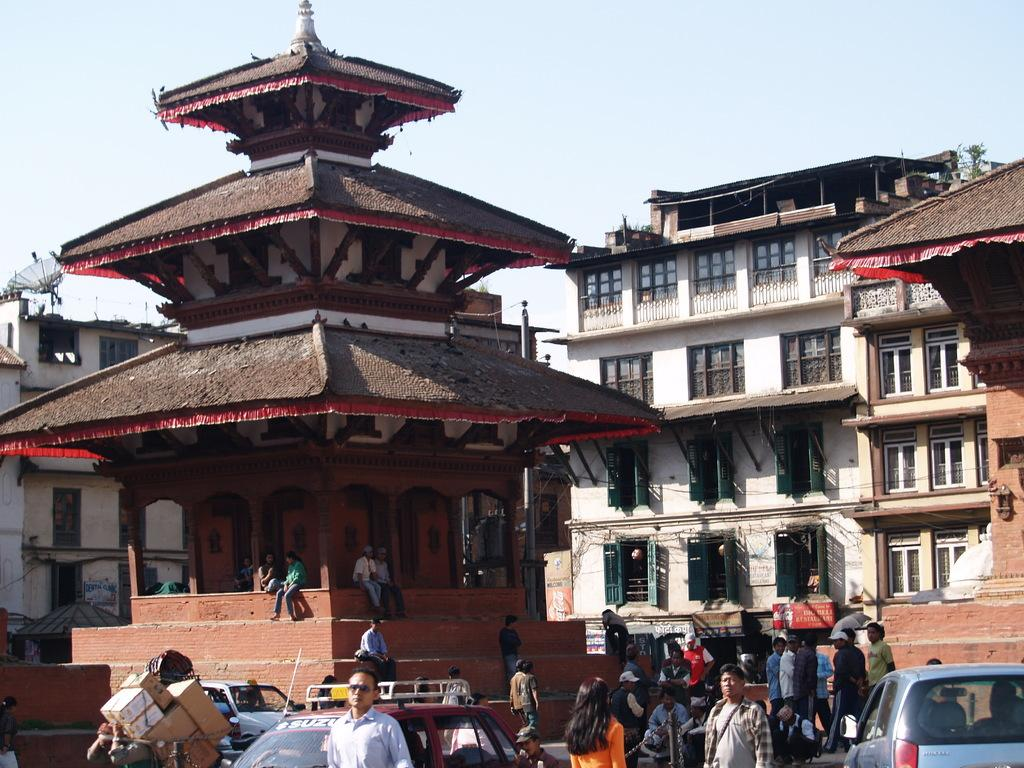Who or what can be seen in the image? There are people and vehicles in the image. What else is present in the image besides people and vehicles? There are boxes, ancient architectures, and buildings visible in the image. What can be seen in the background of the image? Windows, an antenna, and the sky are visible in the background of the image. What type of pail is being used by the people in the image? There is no pail present in the image. How does the tramp interact with the ancient architecture in the image? There is no tramp present in the image; it only features people, vehicles, boxes, ancient architectures, buildings, windows, an antenna, and the sky. 